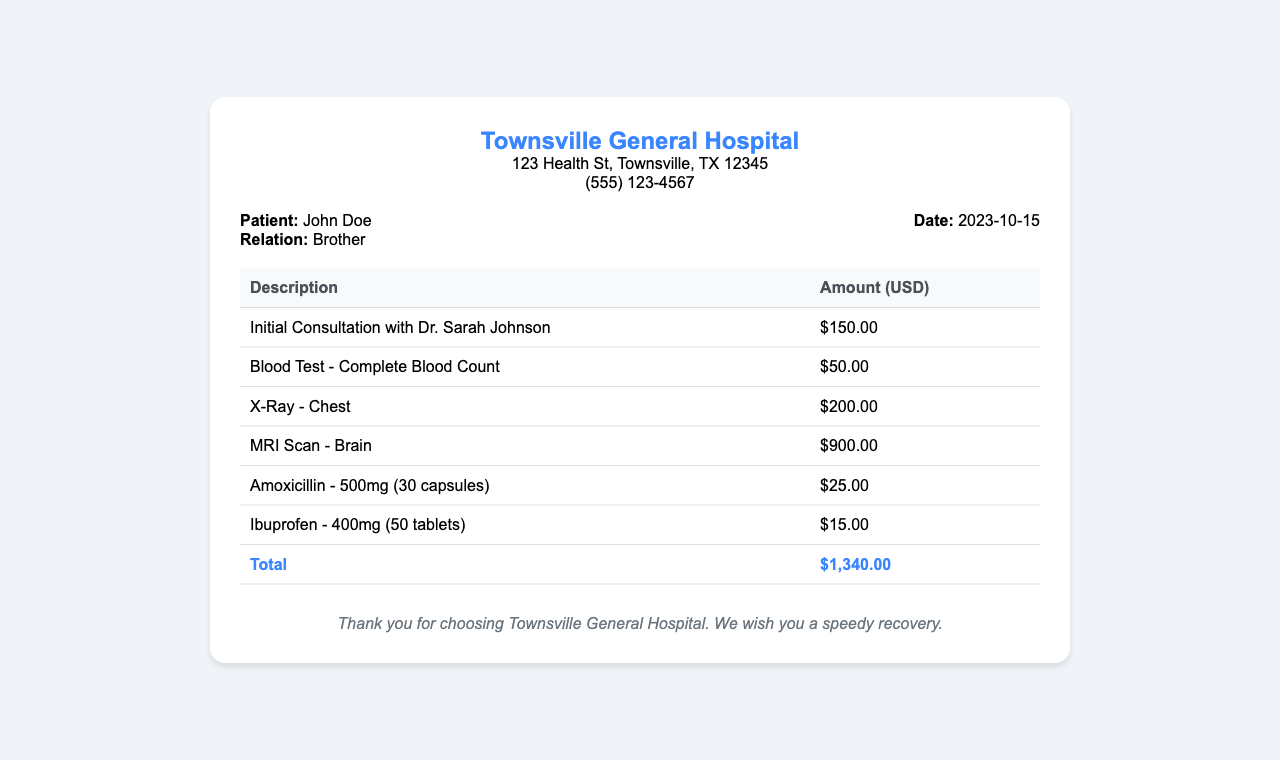What is the name of the hospital? The name of the hospital is prominently displayed at the top of the receipt.
Answer: Townsville General Hospital Who was the consulting doctor? The name of the doctor is listed alongside the initial consultation details.
Answer: Dr. Sarah Johnson What was the date of the hospital visit? The visit date is recorded in the patient information section of the receipt.
Answer: 2023-10-15 How much was charged for the MRI Scan? The cost of the MRI Scan is specified in the treatment charges table.
Answer: $900.00 What is the total amount of the bill? The total amount is calculated and presented at the bottom of the receipt.
Answer: $1,340.00 What medication was prescribed along with its quantity? The prescription details, including the medication name and quantity, are listed in the charges.
Answer: Amoxicillin - 500mg (30 capsules) How much was charged for the X-Ray? The charge for the X-Ray is detailed in the treatment charges table.
Answer: $200.00 What type of test was performed in addition to the consultation? The document includes a specific test performed during the visit, which can be found in the table.
Answer: Blood Test - Complete Blood Count What is the address of the hospital? The address is provided at the top of the receipt, below the hospital name.
Answer: 123 Health St, Townsville, TX 12345 